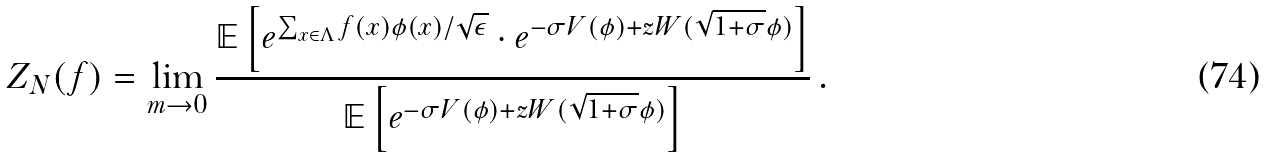<formula> <loc_0><loc_0><loc_500><loc_500>Z _ { N } ( f ) = \lim _ { m \rightarrow 0 } \frac { \mathbb { E } \left [ e ^ { \sum _ { x \in \Lambda } f ( x ) \phi ( x ) / \sqrt { \epsilon } } \cdot e ^ { - \sigma V ( \phi ) + z W ( \sqrt { 1 + \sigma } \phi ) } \right ] } { \mathbb { E } \left [ e ^ { - \sigma V ( \phi ) + z W ( \sqrt { 1 + \sigma } \phi ) } \right ] } \, .</formula> 